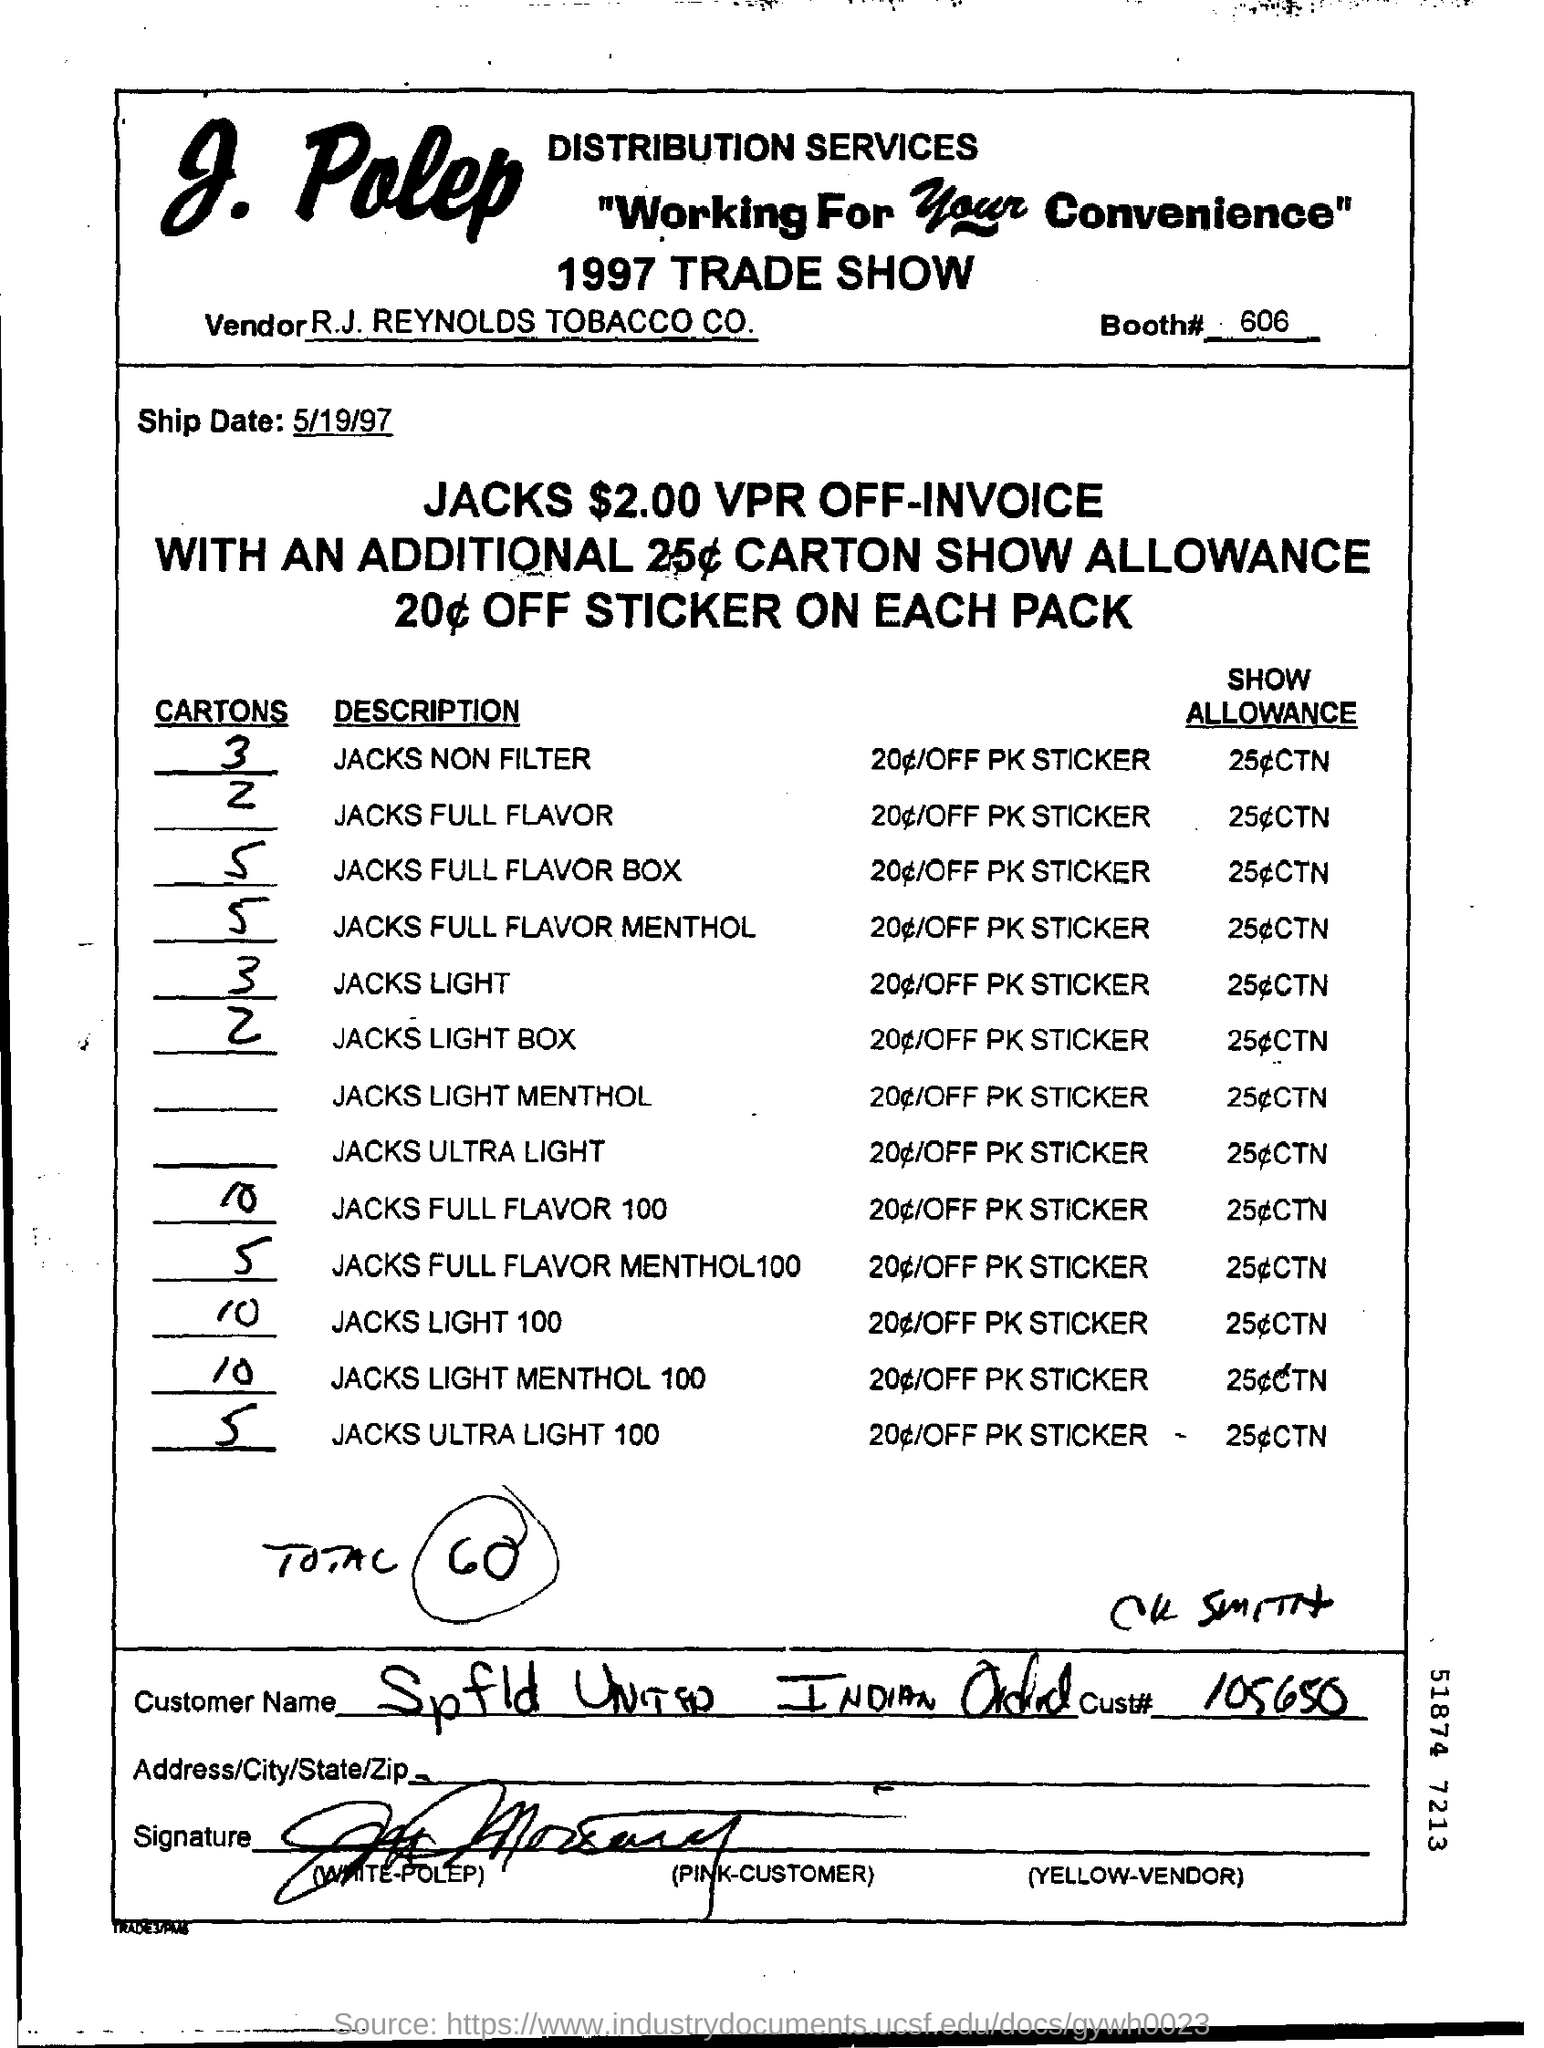What is the booth# number ?
Make the answer very short. 606. What is the vendor name ?
Ensure brevity in your answer.  R.J. Reynolds Tobacco Co. What is the ship date ?
Your response must be concise. 5/19/97. What is the cust# number ?
Provide a succinct answer. 105650. What is the total number mentioned as?
Your answer should be compact. 60. 